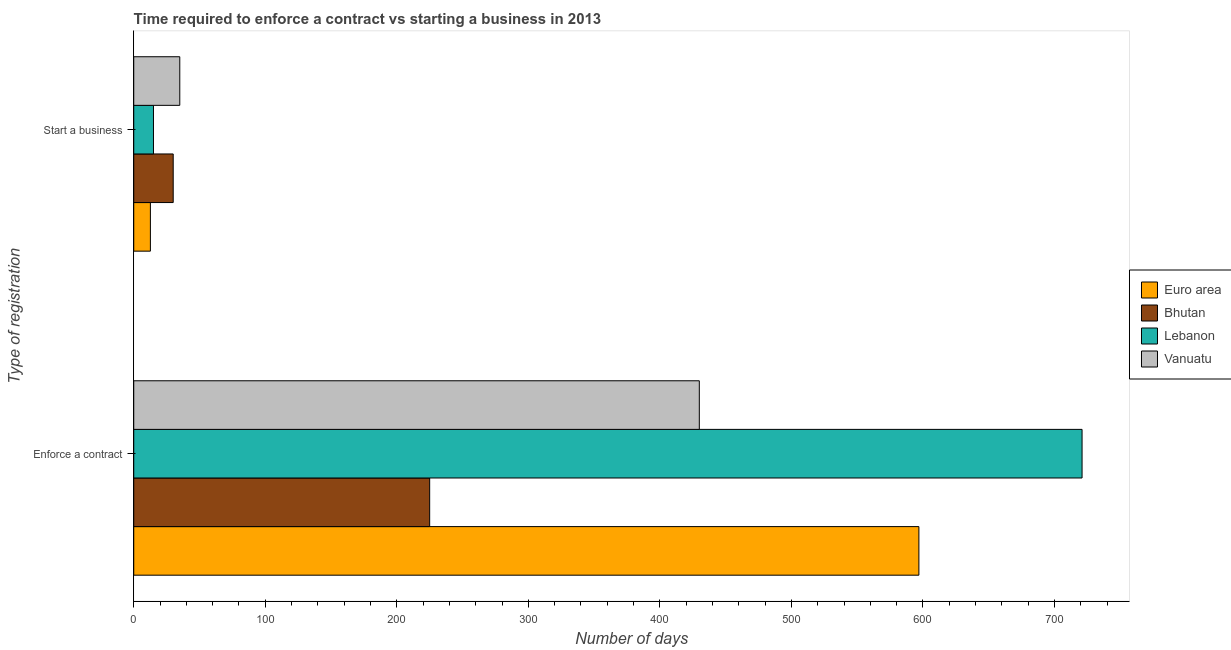How many groups of bars are there?
Your answer should be very brief. 2. How many bars are there on the 1st tick from the top?
Offer a terse response. 4. How many bars are there on the 2nd tick from the bottom?
Give a very brief answer. 4. What is the label of the 1st group of bars from the top?
Ensure brevity in your answer.  Start a business. What is the number of days to enforece a contract in Euro area?
Give a very brief answer. 596.95. Across all countries, what is the minimum number of days to enforece a contract?
Your answer should be compact. 225. In which country was the number of days to enforece a contract maximum?
Make the answer very short. Lebanon. In which country was the number of days to enforece a contract minimum?
Your answer should be very brief. Bhutan. What is the total number of days to start a business in the graph?
Offer a very short reply. 92.66. What is the difference between the number of days to enforece a contract in Euro area and that in Lebanon?
Provide a short and direct response. -124.05. What is the difference between the number of days to start a business in Euro area and the number of days to enforece a contract in Lebanon?
Ensure brevity in your answer.  -708.34. What is the average number of days to start a business per country?
Make the answer very short. 23.16. What is the difference between the number of days to enforece a contract and number of days to start a business in Bhutan?
Provide a succinct answer. 195. What is the ratio of the number of days to start a business in Euro area to that in Lebanon?
Provide a succinct answer. 0.84. What does the 1st bar from the top in Start a business represents?
Your answer should be compact. Vanuatu. What does the 3rd bar from the bottom in Enforce a contract represents?
Give a very brief answer. Lebanon. What is the difference between two consecutive major ticks on the X-axis?
Offer a terse response. 100. Are the values on the major ticks of X-axis written in scientific E-notation?
Make the answer very short. No. Does the graph contain any zero values?
Keep it short and to the point. No. Does the graph contain grids?
Your response must be concise. No. How are the legend labels stacked?
Provide a short and direct response. Vertical. What is the title of the graph?
Your answer should be very brief. Time required to enforce a contract vs starting a business in 2013. What is the label or title of the X-axis?
Offer a very short reply. Number of days. What is the label or title of the Y-axis?
Provide a succinct answer. Type of registration. What is the Number of days in Euro area in Enforce a contract?
Make the answer very short. 596.95. What is the Number of days of Bhutan in Enforce a contract?
Your answer should be compact. 225. What is the Number of days in Lebanon in Enforce a contract?
Provide a short and direct response. 721. What is the Number of days in Vanuatu in Enforce a contract?
Give a very brief answer. 430. What is the Number of days in Euro area in Start a business?
Give a very brief answer. 12.66. What is the Number of days of Bhutan in Start a business?
Provide a short and direct response. 30. Across all Type of registration, what is the maximum Number of days of Euro area?
Provide a succinct answer. 596.95. Across all Type of registration, what is the maximum Number of days of Bhutan?
Provide a short and direct response. 225. Across all Type of registration, what is the maximum Number of days of Lebanon?
Ensure brevity in your answer.  721. Across all Type of registration, what is the maximum Number of days of Vanuatu?
Your response must be concise. 430. Across all Type of registration, what is the minimum Number of days of Euro area?
Keep it short and to the point. 12.66. Across all Type of registration, what is the minimum Number of days in Bhutan?
Give a very brief answer. 30. Across all Type of registration, what is the minimum Number of days in Vanuatu?
Give a very brief answer. 35. What is the total Number of days of Euro area in the graph?
Your answer should be very brief. 609.61. What is the total Number of days of Bhutan in the graph?
Ensure brevity in your answer.  255. What is the total Number of days of Lebanon in the graph?
Your answer should be compact. 736. What is the total Number of days in Vanuatu in the graph?
Offer a terse response. 465. What is the difference between the Number of days in Euro area in Enforce a contract and that in Start a business?
Ensure brevity in your answer.  584.29. What is the difference between the Number of days in Bhutan in Enforce a contract and that in Start a business?
Your answer should be very brief. 195. What is the difference between the Number of days of Lebanon in Enforce a contract and that in Start a business?
Provide a short and direct response. 706. What is the difference between the Number of days of Vanuatu in Enforce a contract and that in Start a business?
Provide a succinct answer. 395. What is the difference between the Number of days of Euro area in Enforce a contract and the Number of days of Bhutan in Start a business?
Ensure brevity in your answer.  566.95. What is the difference between the Number of days of Euro area in Enforce a contract and the Number of days of Lebanon in Start a business?
Your answer should be compact. 581.95. What is the difference between the Number of days of Euro area in Enforce a contract and the Number of days of Vanuatu in Start a business?
Provide a short and direct response. 561.95. What is the difference between the Number of days in Bhutan in Enforce a contract and the Number of days in Lebanon in Start a business?
Make the answer very short. 210. What is the difference between the Number of days in Bhutan in Enforce a contract and the Number of days in Vanuatu in Start a business?
Keep it short and to the point. 190. What is the difference between the Number of days in Lebanon in Enforce a contract and the Number of days in Vanuatu in Start a business?
Offer a very short reply. 686. What is the average Number of days of Euro area per Type of registration?
Offer a very short reply. 304.8. What is the average Number of days in Bhutan per Type of registration?
Provide a succinct answer. 127.5. What is the average Number of days of Lebanon per Type of registration?
Your response must be concise. 368. What is the average Number of days in Vanuatu per Type of registration?
Offer a terse response. 232.5. What is the difference between the Number of days in Euro area and Number of days in Bhutan in Enforce a contract?
Offer a terse response. 371.95. What is the difference between the Number of days in Euro area and Number of days in Lebanon in Enforce a contract?
Your response must be concise. -124.05. What is the difference between the Number of days in Euro area and Number of days in Vanuatu in Enforce a contract?
Provide a short and direct response. 166.95. What is the difference between the Number of days in Bhutan and Number of days in Lebanon in Enforce a contract?
Provide a short and direct response. -496. What is the difference between the Number of days of Bhutan and Number of days of Vanuatu in Enforce a contract?
Keep it short and to the point. -205. What is the difference between the Number of days in Lebanon and Number of days in Vanuatu in Enforce a contract?
Offer a terse response. 291. What is the difference between the Number of days in Euro area and Number of days in Bhutan in Start a business?
Provide a succinct answer. -17.34. What is the difference between the Number of days in Euro area and Number of days in Lebanon in Start a business?
Offer a very short reply. -2.34. What is the difference between the Number of days of Euro area and Number of days of Vanuatu in Start a business?
Your response must be concise. -22.34. What is the difference between the Number of days of Lebanon and Number of days of Vanuatu in Start a business?
Provide a succinct answer. -20. What is the ratio of the Number of days in Euro area in Enforce a contract to that in Start a business?
Ensure brevity in your answer.  47.16. What is the ratio of the Number of days of Lebanon in Enforce a contract to that in Start a business?
Ensure brevity in your answer.  48.07. What is the ratio of the Number of days in Vanuatu in Enforce a contract to that in Start a business?
Ensure brevity in your answer.  12.29. What is the difference between the highest and the second highest Number of days of Euro area?
Offer a terse response. 584.29. What is the difference between the highest and the second highest Number of days of Bhutan?
Offer a terse response. 195. What is the difference between the highest and the second highest Number of days of Lebanon?
Make the answer very short. 706. What is the difference between the highest and the second highest Number of days in Vanuatu?
Ensure brevity in your answer.  395. What is the difference between the highest and the lowest Number of days in Euro area?
Keep it short and to the point. 584.29. What is the difference between the highest and the lowest Number of days in Bhutan?
Ensure brevity in your answer.  195. What is the difference between the highest and the lowest Number of days in Lebanon?
Provide a succinct answer. 706. What is the difference between the highest and the lowest Number of days of Vanuatu?
Provide a succinct answer. 395. 